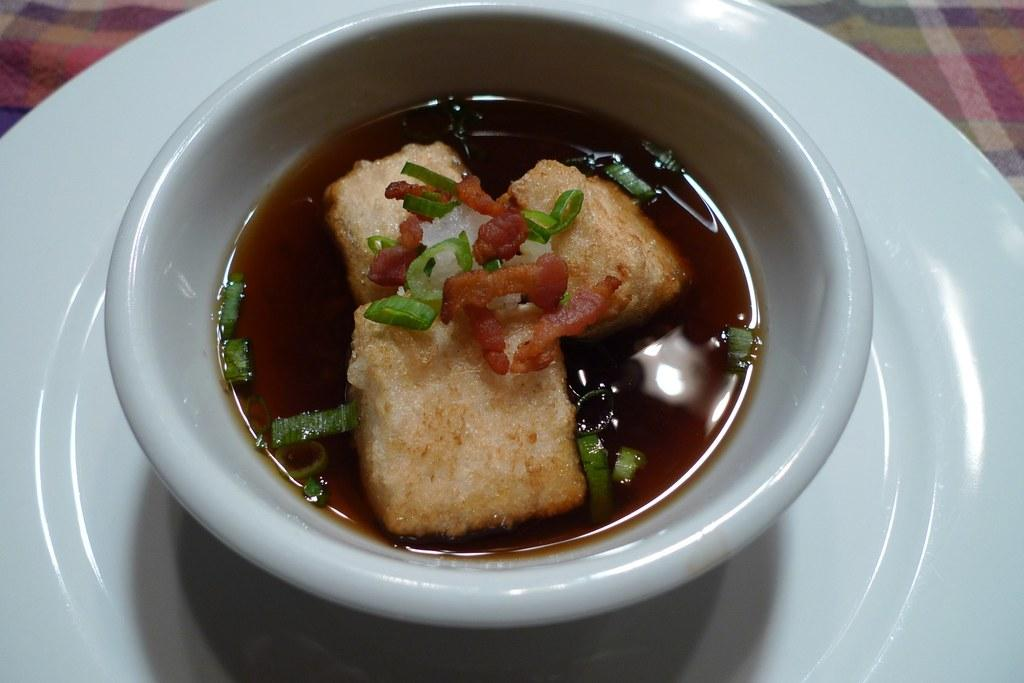What is in the bowl that is visible in the image? There is a food item in the bowl in the image. How is the bowl positioned on the plate? The bowl is placed on a plate in the image. What can be seen in the top left corner of the image? There is a cloth in the top left corner of the image. What can be seen in the top right corner of the image? There is a cloth in the top right corner of the image. What part of the brain is responsible for the impulse to eat the food item in the image? The image does not provide information about the brain or any impulses related to the food item. 